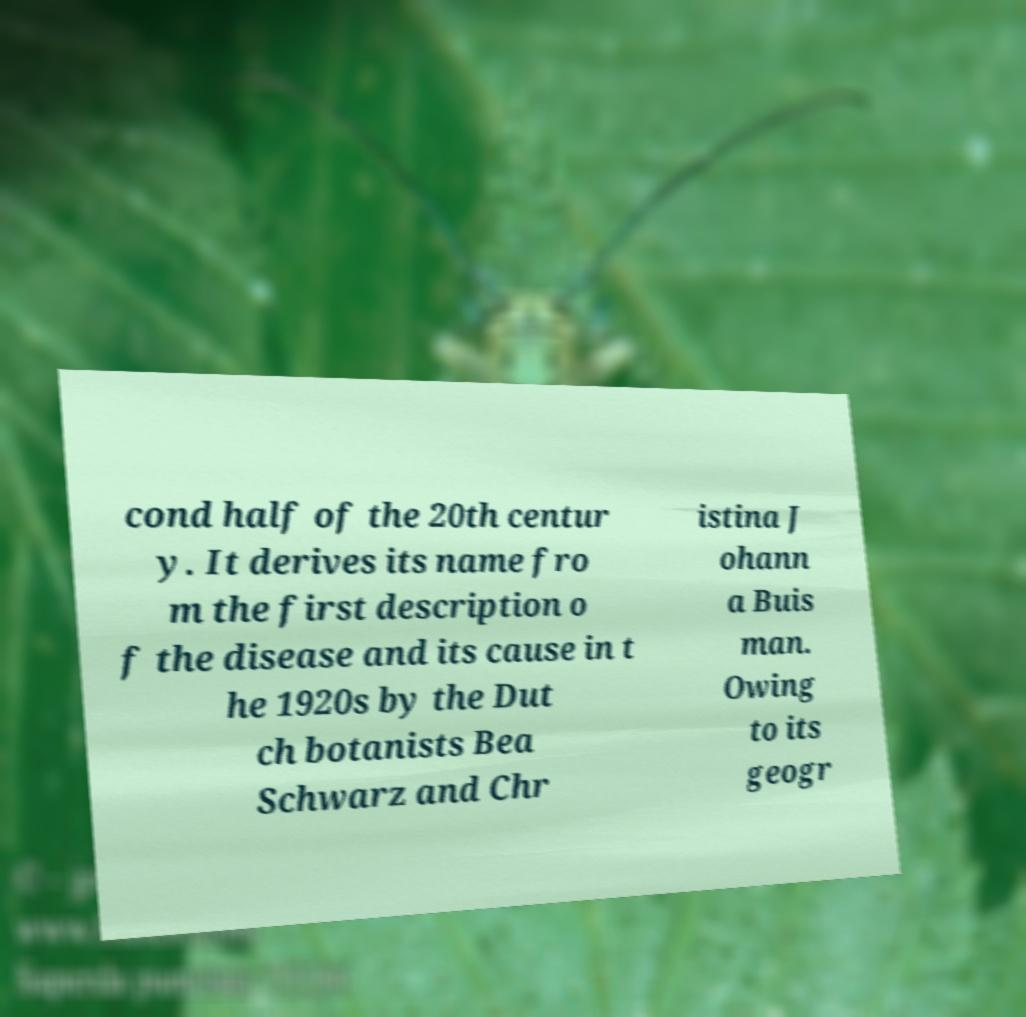Can you read and provide the text displayed in the image?This photo seems to have some interesting text. Can you extract and type it out for me? cond half of the 20th centur y. It derives its name fro m the first description o f the disease and its cause in t he 1920s by the Dut ch botanists Bea Schwarz and Chr istina J ohann a Buis man. Owing to its geogr 